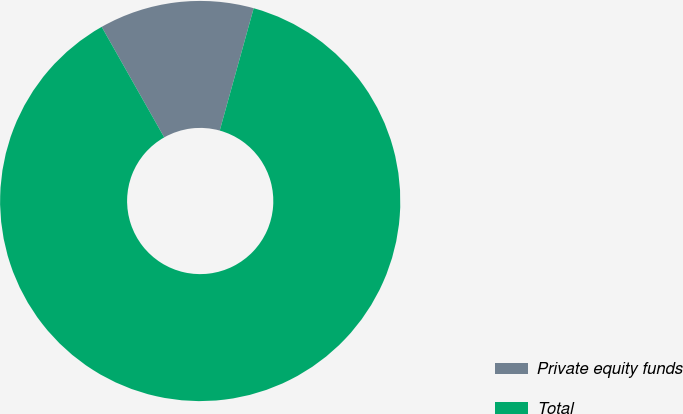Convert chart. <chart><loc_0><loc_0><loc_500><loc_500><pie_chart><fcel>Private equity funds<fcel>Total<nl><fcel>12.5%<fcel>87.5%<nl></chart> 